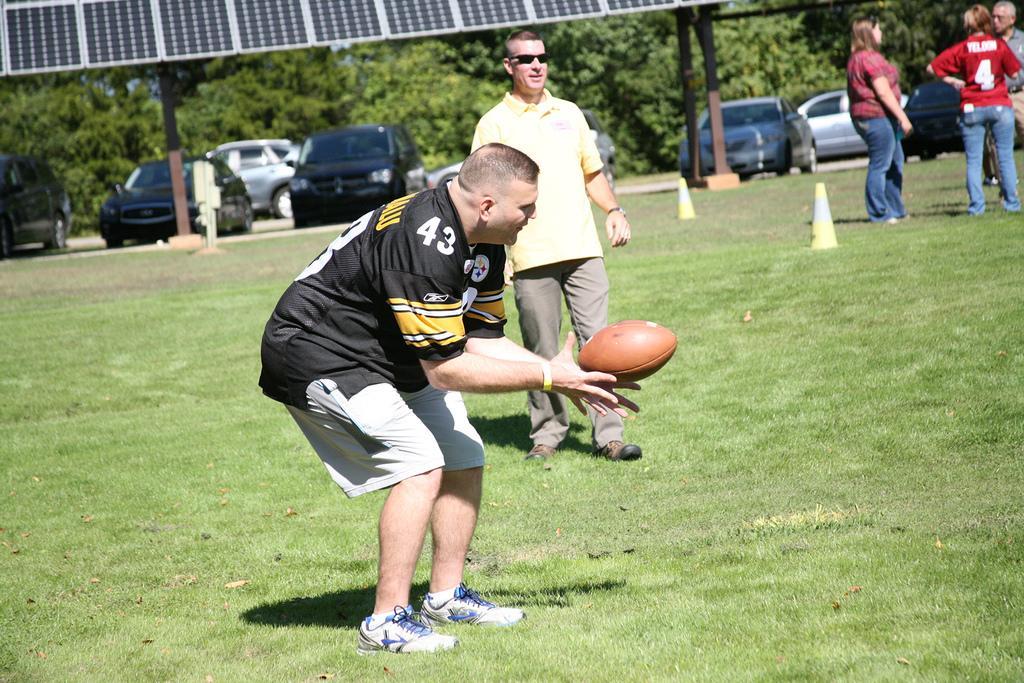Describe this image in one or two sentences. This picture describe about a five people in the ground in which a person the front wearing black color T- shirt and spots playing soccer game behind him a person with yellow color t-shirt and pant, behind there are many trees and park vehicle, and on the green field they are traffic cones and woman standing wearing pink shirt and beside her another woman wearing red t-shirt. 